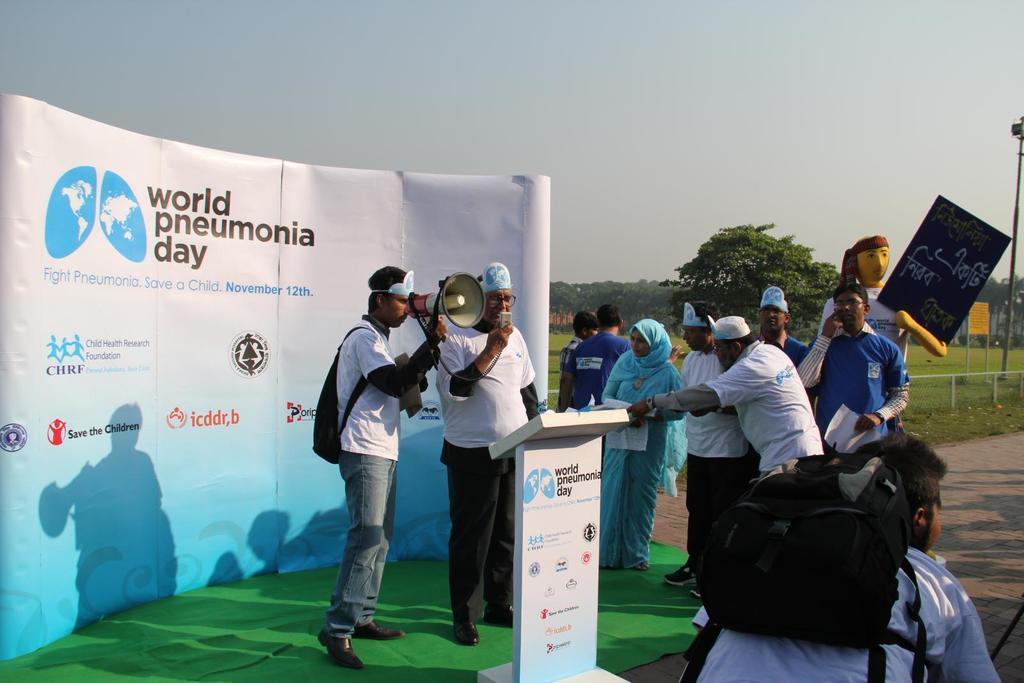Describe this image in one or two sentences. In this image, we can see a group of people are standing. Few are holding some objects. Here a person is wearing a backpack and there is a podium. Background we can see banner, trees, poles, boards and clear sky. 